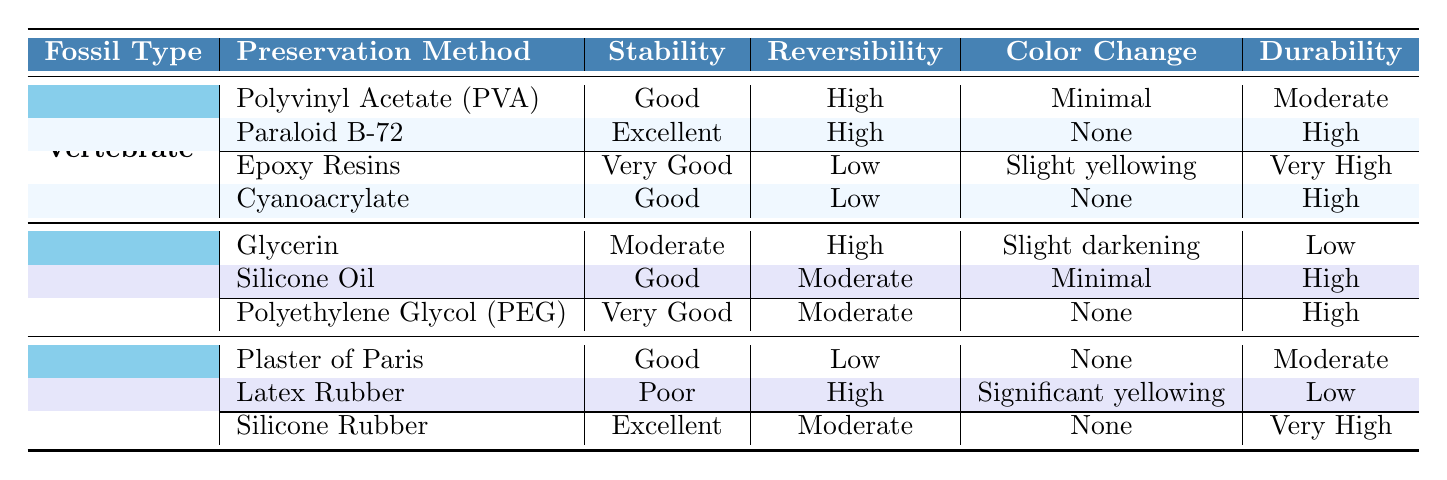What preservation method for Vertebrate fossils has the highest stability? In the table, the "Stability" column for Vertebrate fossils indicates that the method with the highest stability is "Paraloid B-72," which is labeled as "Excellent."
Answer: Paraloid B-72 Which preservation method for Plant fossils has the lowest durability? Reviewing the "Durability" category for Plant fossils, "Glycerin" has the lowest durability rating marked as "Low."
Answer: Glycerin Is the color change for Epoxy Resins significant? Looking at the "Color Change" entry for Epoxy Resins in the Vertebrate fossils section, it states "Slight yellowing," which is not significant compared to "None" or "Significant yellowing."
Answer: No What is the average stability rating for preservation methods used for Trace fossils? The stability ratings for Trace fossils are Good, Poor, and Excellent. The numerical equivalents are Good (3), Poor (1), and Excellent (5). Averaging these gives (3 + 1 + 5) / 3 = 3.
Answer: 3 Which preservation method for Vertebrate fossils is reversible? In the "Reversibility" column for Vertebrate fossils, both "Polyvinyl Acetate (PVA)" and "Paraloid B-72" are marked as "High," indicating they are reversible.
Answer: Polyvinyl Acetate (PVA) and Paraloid B-72 How many preservation methods for Plant fossils have a "Good" stability rating? Checking the "Stability" ratings for Plant fossils, "Silicone Oil" and "PEG" are labeled as "Good" and "Very Good," respectively. There is only one method with "Good" stability directly noted, which is "Silicone Oil."
Answer: 1 What preservation method has the highest durability across all fossil types? Looking at the "Durability" ratings, both "Epoxy Resins" and "Silicone Rubber" list "Very High" as their durability status, indicating a tie.
Answer: Epoxy Resins and Silicone Rubber Which fossil type has a preservation method that shows significant yellowing? Reviewing the "Color Change" column, "Latex Rubber" under Trace fossils is marked with "Significant yellowing," indicating it’s the only method noted for this effect.
Answer: Trace fossils If you use "Polyethylene Glycol (PEG)" for Plant fossils, how does the stability compare to "Glycerin"? Stability for PEG is noted as "Very Good," whereas "Glycerin" is listed as "Moderate." Comparing these two indicates PEG has a higher stability status.
Answer: PEG is better Which storage container is best suited for all types of fossils based on durability? The table does not specify durability ratings for storage containers, so we must infer that acid-free boxes and glass vials are generally considered more suitable due to their lack of chemical degradation.
Answer: Acid-free Boxes and Glass Vials 